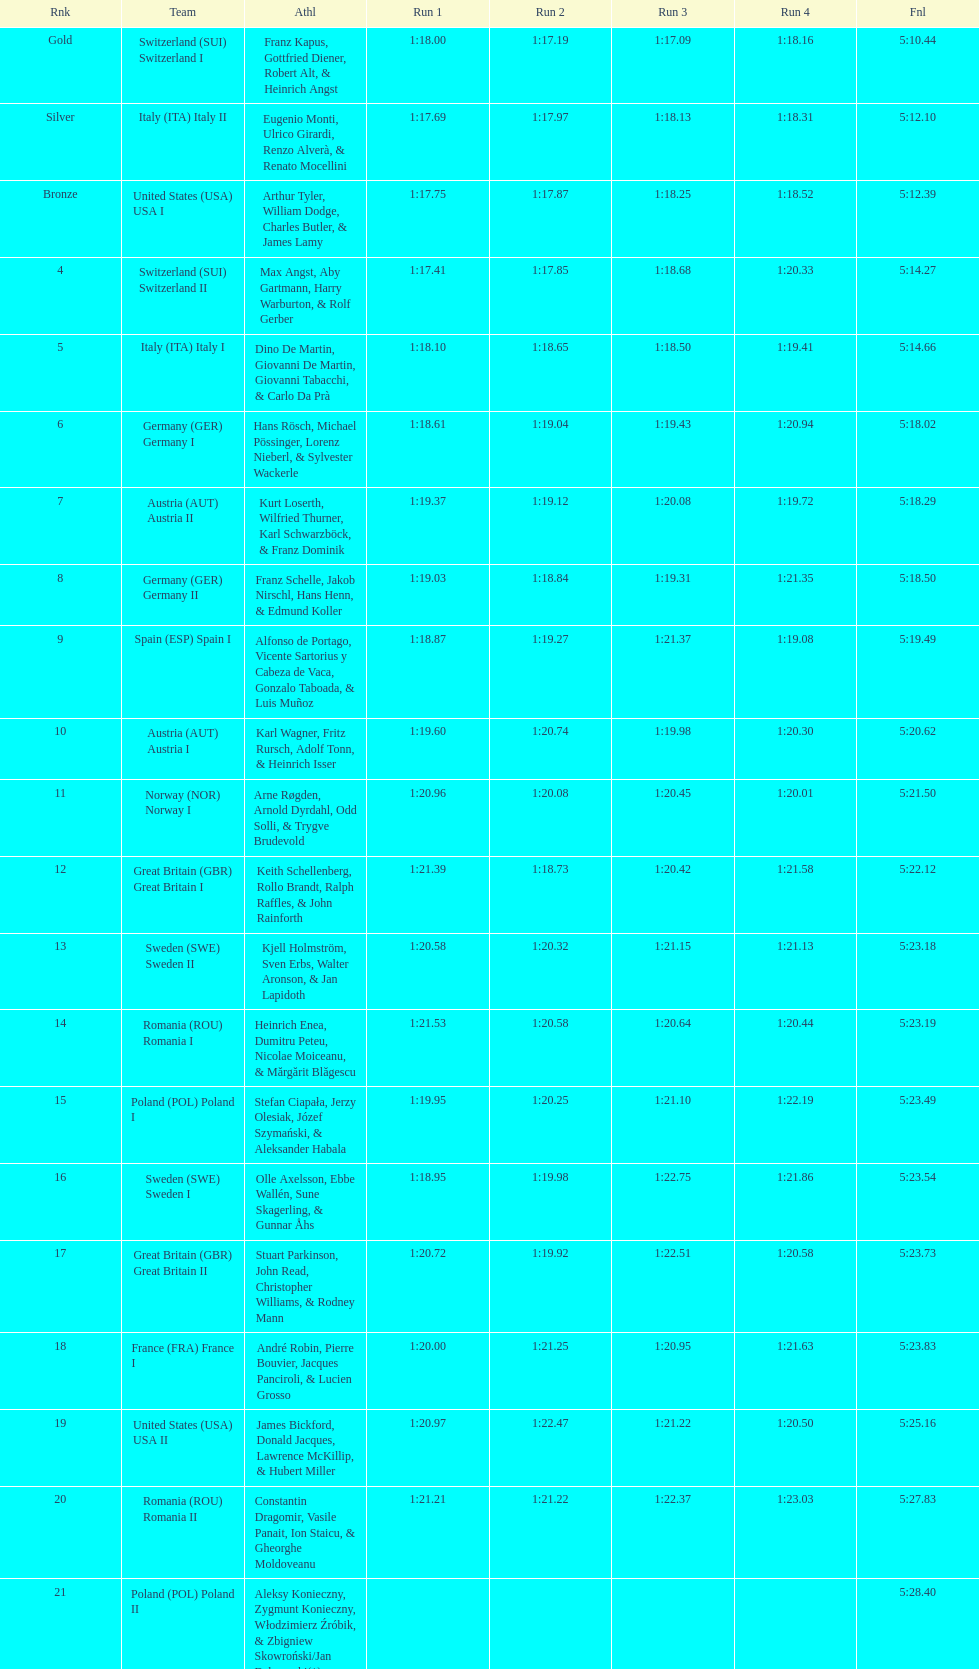What team comes after italy (ita) italy i? Germany I. 